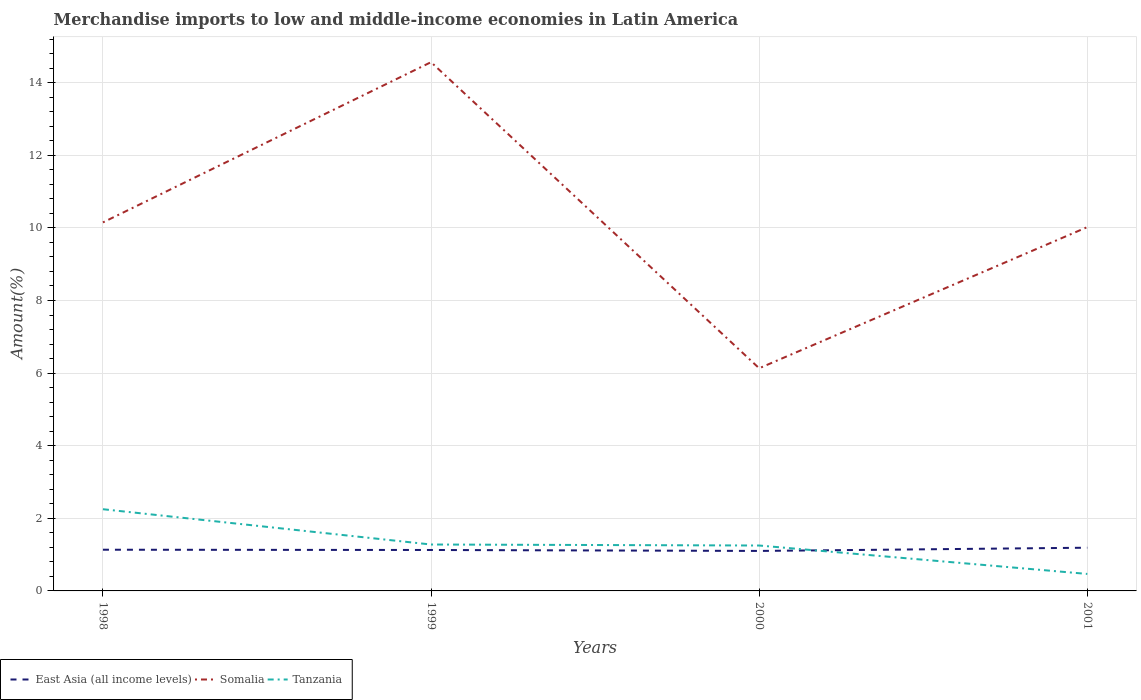How many different coloured lines are there?
Provide a succinct answer. 3. Is the number of lines equal to the number of legend labels?
Offer a terse response. Yes. Across all years, what is the maximum percentage of amount earned from merchandise imports in Somalia?
Your answer should be very brief. 6.13. In which year was the percentage of amount earned from merchandise imports in Somalia maximum?
Your response must be concise. 2000. What is the total percentage of amount earned from merchandise imports in Somalia in the graph?
Provide a succinct answer. 4.02. What is the difference between the highest and the second highest percentage of amount earned from merchandise imports in Somalia?
Your response must be concise. 8.43. What is the difference between two consecutive major ticks on the Y-axis?
Offer a very short reply. 2. Are the values on the major ticks of Y-axis written in scientific E-notation?
Your answer should be compact. No. Does the graph contain any zero values?
Make the answer very short. No. Does the graph contain grids?
Give a very brief answer. Yes. Where does the legend appear in the graph?
Offer a terse response. Bottom left. How are the legend labels stacked?
Give a very brief answer. Horizontal. What is the title of the graph?
Offer a very short reply. Merchandise imports to low and middle-income economies in Latin America. Does "Jamaica" appear as one of the legend labels in the graph?
Your response must be concise. No. What is the label or title of the X-axis?
Offer a very short reply. Years. What is the label or title of the Y-axis?
Your answer should be compact. Amount(%). What is the Amount(%) of East Asia (all income levels) in 1998?
Keep it short and to the point. 1.13. What is the Amount(%) of Somalia in 1998?
Keep it short and to the point. 10.15. What is the Amount(%) in Tanzania in 1998?
Your answer should be compact. 2.25. What is the Amount(%) of East Asia (all income levels) in 1999?
Ensure brevity in your answer.  1.13. What is the Amount(%) of Somalia in 1999?
Your answer should be very brief. 14.57. What is the Amount(%) of Tanzania in 1999?
Ensure brevity in your answer.  1.28. What is the Amount(%) of East Asia (all income levels) in 2000?
Keep it short and to the point. 1.1. What is the Amount(%) in Somalia in 2000?
Offer a terse response. 6.13. What is the Amount(%) in Tanzania in 2000?
Give a very brief answer. 1.25. What is the Amount(%) in East Asia (all income levels) in 2001?
Provide a succinct answer. 1.19. What is the Amount(%) of Somalia in 2001?
Your answer should be compact. 10.02. What is the Amount(%) of Tanzania in 2001?
Give a very brief answer. 0.47. Across all years, what is the maximum Amount(%) in East Asia (all income levels)?
Keep it short and to the point. 1.19. Across all years, what is the maximum Amount(%) in Somalia?
Keep it short and to the point. 14.57. Across all years, what is the maximum Amount(%) of Tanzania?
Provide a succinct answer. 2.25. Across all years, what is the minimum Amount(%) in East Asia (all income levels)?
Offer a very short reply. 1.1. Across all years, what is the minimum Amount(%) of Somalia?
Keep it short and to the point. 6.13. Across all years, what is the minimum Amount(%) of Tanzania?
Provide a short and direct response. 0.47. What is the total Amount(%) in East Asia (all income levels) in the graph?
Make the answer very short. 4.55. What is the total Amount(%) in Somalia in the graph?
Your answer should be very brief. 40.87. What is the total Amount(%) in Tanzania in the graph?
Your response must be concise. 5.25. What is the difference between the Amount(%) in East Asia (all income levels) in 1998 and that in 1999?
Your answer should be very brief. 0.01. What is the difference between the Amount(%) of Somalia in 1998 and that in 1999?
Provide a short and direct response. -4.41. What is the difference between the Amount(%) in Tanzania in 1998 and that in 1999?
Provide a short and direct response. 0.97. What is the difference between the Amount(%) of East Asia (all income levels) in 1998 and that in 2000?
Ensure brevity in your answer.  0.03. What is the difference between the Amount(%) in Somalia in 1998 and that in 2000?
Your response must be concise. 4.02. What is the difference between the Amount(%) of Tanzania in 1998 and that in 2000?
Your answer should be very brief. 1. What is the difference between the Amount(%) of East Asia (all income levels) in 1998 and that in 2001?
Give a very brief answer. -0.06. What is the difference between the Amount(%) in Somalia in 1998 and that in 2001?
Your answer should be compact. 0.13. What is the difference between the Amount(%) of Tanzania in 1998 and that in 2001?
Your response must be concise. 1.78. What is the difference between the Amount(%) in East Asia (all income levels) in 1999 and that in 2000?
Make the answer very short. 0.03. What is the difference between the Amount(%) of Somalia in 1999 and that in 2000?
Offer a very short reply. 8.43. What is the difference between the Amount(%) of Tanzania in 1999 and that in 2000?
Ensure brevity in your answer.  0.03. What is the difference between the Amount(%) in East Asia (all income levels) in 1999 and that in 2001?
Provide a succinct answer. -0.06. What is the difference between the Amount(%) of Somalia in 1999 and that in 2001?
Offer a very short reply. 4.54. What is the difference between the Amount(%) of Tanzania in 1999 and that in 2001?
Your response must be concise. 0.81. What is the difference between the Amount(%) in East Asia (all income levels) in 2000 and that in 2001?
Offer a terse response. -0.09. What is the difference between the Amount(%) of Somalia in 2000 and that in 2001?
Make the answer very short. -3.89. What is the difference between the Amount(%) in Tanzania in 2000 and that in 2001?
Make the answer very short. 0.78. What is the difference between the Amount(%) in East Asia (all income levels) in 1998 and the Amount(%) in Somalia in 1999?
Ensure brevity in your answer.  -13.43. What is the difference between the Amount(%) of East Asia (all income levels) in 1998 and the Amount(%) of Tanzania in 1999?
Give a very brief answer. -0.14. What is the difference between the Amount(%) of Somalia in 1998 and the Amount(%) of Tanzania in 1999?
Offer a very short reply. 8.87. What is the difference between the Amount(%) of East Asia (all income levels) in 1998 and the Amount(%) of Somalia in 2000?
Offer a very short reply. -5. What is the difference between the Amount(%) in East Asia (all income levels) in 1998 and the Amount(%) in Tanzania in 2000?
Your response must be concise. -0.12. What is the difference between the Amount(%) of Somalia in 1998 and the Amount(%) of Tanzania in 2000?
Provide a short and direct response. 8.9. What is the difference between the Amount(%) in East Asia (all income levels) in 1998 and the Amount(%) in Somalia in 2001?
Provide a succinct answer. -8.89. What is the difference between the Amount(%) in East Asia (all income levels) in 1998 and the Amount(%) in Tanzania in 2001?
Your answer should be very brief. 0.67. What is the difference between the Amount(%) of Somalia in 1998 and the Amount(%) of Tanzania in 2001?
Make the answer very short. 9.68. What is the difference between the Amount(%) in East Asia (all income levels) in 1999 and the Amount(%) in Somalia in 2000?
Offer a very short reply. -5.01. What is the difference between the Amount(%) in East Asia (all income levels) in 1999 and the Amount(%) in Tanzania in 2000?
Offer a very short reply. -0.12. What is the difference between the Amount(%) in Somalia in 1999 and the Amount(%) in Tanzania in 2000?
Offer a terse response. 13.31. What is the difference between the Amount(%) of East Asia (all income levels) in 1999 and the Amount(%) of Somalia in 2001?
Offer a very short reply. -8.89. What is the difference between the Amount(%) of East Asia (all income levels) in 1999 and the Amount(%) of Tanzania in 2001?
Provide a succinct answer. 0.66. What is the difference between the Amount(%) of Somalia in 1999 and the Amount(%) of Tanzania in 2001?
Provide a short and direct response. 14.1. What is the difference between the Amount(%) of East Asia (all income levels) in 2000 and the Amount(%) of Somalia in 2001?
Offer a very short reply. -8.92. What is the difference between the Amount(%) of East Asia (all income levels) in 2000 and the Amount(%) of Tanzania in 2001?
Provide a succinct answer. 0.63. What is the difference between the Amount(%) in Somalia in 2000 and the Amount(%) in Tanzania in 2001?
Keep it short and to the point. 5.67. What is the average Amount(%) of East Asia (all income levels) per year?
Provide a short and direct response. 1.14. What is the average Amount(%) in Somalia per year?
Your answer should be compact. 10.22. What is the average Amount(%) of Tanzania per year?
Your answer should be compact. 1.31. In the year 1998, what is the difference between the Amount(%) of East Asia (all income levels) and Amount(%) of Somalia?
Make the answer very short. -9.02. In the year 1998, what is the difference between the Amount(%) of East Asia (all income levels) and Amount(%) of Tanzania?
Offer a very short reply. -1.12. In the year 1998, what is the difference between the Amount(%) in Somalia and Amount(%) in Tanzania?
Your answer should be compact. 7.9. In the year 1999, what is the difference between the Amount(%) in East Asia (all income levels) and Amount(%) in Somalia?
Keep it short and to the point. -13.44. In the year 1999, what is the difference between the Amount(%) in East Asia (all income levels) and Amount(%) in Tanzania?
Make the answer very short. -0.15. In the year 1999, what is the difference between the Amount(%) of Somalia and Amount(%) of Tanzania?
Ensure brevity in your answer.  13.29. In the year 2000, what is the difference between the Amount(%) of East Asia (all income levels) and Amount(%) of Somalia?
Your response must be concise. -5.03. In the year 2000, what is the difference between the Amount(%) of East Asia (all income levels) and Amount(%) of Tanzania?
Give a very brief answer. -0.15. In the year 2000, what is the difference between the Amount(%) in Somalia and Amount(%) in Tanzania?
Ensure brevity in your answer.  4.88. In the year 2001, what is the difference between the Amount(%) in East Asia (all income levels) and Amount(%) in Somalia?
Ensure brevity in your answer.  -8.83. In the year 2001, what is the difference between the Amount(%) in East Asia (all income levels) and Amount(%) in Tanzania?
Provide a succinct answer. 0.72. In the year 2001, what is the difference between the Amount(%) in Somalia and Amount(%) in Tanzania?
Provide a succinct answer. 9.55. What is the ratio of the Amount(%) of East Asia (all income levels) in 1998 to that in 1999?
Provide a short and direct response. 1.01. What is the ratio of the Amount(%) in Somalia in 1998 to that in 1999?
Ensure brevity in your answer.  0.7. What is the ratio of the Amount(%) of Tanzania in 1998 to that in 1999?
Give a very brief answer. 1.76. What is the ratio of the Amount(%) in East Asia (all income levels) in 1998 to that in 2000?
Provide a short and direct response. 1.03. What is the ratio of the Amount(%) in Somalia in 1998 to that in 2000?
Give a very brief answer. 1.66. What is the ratio of the Amount(%) in Tanzania in 1998 to that in 2000?
Make the answer very short. 1.8. What is the ratio of the Amount(%) of East Asia (all income levels) in 1998 to that in 2001?
Keep it short and to the point. 0.95. What is the ratio of the Amount(%) of Somalia in 1998 to that in 2001?
Keep it short and to the point. 1.01. What is the ratio of the Amount(%) in Tanzania in 1998 to that in 2001?
Provide a succinct answer. 4.81. What is the ratio of the Amount(%) in East Asia (all income levels) in 1999 to that in 2000?
Provide a short and direct response. 1.02. What is the ratio of the Amount(%) of Somalia in 1999 to that in 2000?
Provide a succinct answer. 2.37. What is the ratio of the Amount(%) of East Asia (all income levels) in 1999 to that in 2001?
Offer a very short reply. 0.95. What is the ratio of the Amount(%) of Somalia in 1999 to that in 2001?
Keep it short and to the point. 1.45. What is the ratio of the Amount(%) in Tanzania in 1999 to that in 2001?
Your response must be concise. 2.73. What is the ratio of the Amount(%) in East Asia (all income levels) in 2000 to that in 2001?
Provide a succinct answer. 0.93. What is the ratio of the Amount(%) of Somalia in 2000 to that in 2001?
Give a very brief answer. 0.61. What is the ratio of the Amount(%) in Tanzania in 2000 to that in 2001?
Your answer should be compact. 2.67. What is the difference between the highest and the second highest Amount(%) of East Asia (all income levels)?
Your answer should be very brief. 0.06. What is the difference between the highest and the second highest Amount(%) of Somalia?
Your answer should be very brief. 4.41. What is the difference between the highest and the second highest Amount(%) of Tanzania?
Provide a succinct answer. 0.97. What is the difference between the highest and the lowest Amount(%) of East Asia (all income levels)?
Provide a short and direct response. 0.09. What is the difference between the highest and the lowest Amount(%) of Somalia?
Ensure brevity in your answer.  8.43. What is the difference between the highest and the lowest Amount(%) in Tanzania?
Keep it short and to the point. 1.78. 